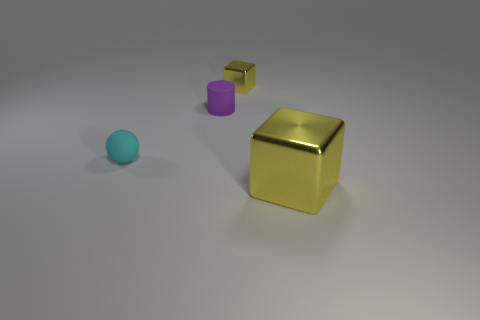What material is the tiny object that is the same shape as the large shiny thing?
Provide a succinct answer. Metal. Are there any other things that are the same size as the purple matte thing?
Offer a very short reply. Yes. Are any blue rubber objects visible?
Provide a succinct answer. No. There is a yellow thing right of the shiny object behind the metal block to the right of the tiny yellow block; what is it made of?
Offer a very short reply. Metal. There is a tiny purple matte thing; does it have the same shape as the shiny object behind the cyan sphere?
Make the answer very short. No. What number of metallic objects are the same shape as the purple rubber object?
Provide a short and direct response. 0. What shape is the tiny yellow metal object?
Offer a terse response. Cube. What size is the yellow metallic thing that is in front of the yellow object that is behind the large metal thing?
Your answer should be very brief. Large. How many things are either tiny yellow blocks or large things?
Provide a succinct answer. 2. Do the purple matte object and the large shiny object have the same shape?
Your answer should be compact. No. 